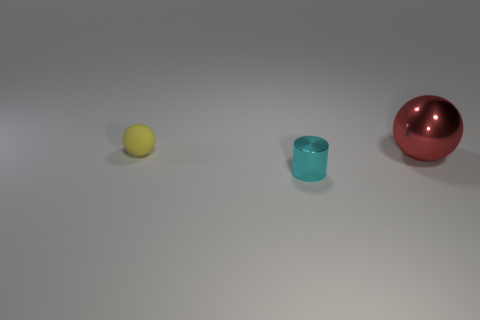Are there any other things that are made of the same material as the yellow sphere?
Provide a succinct answer. No. Is there anything else that is the same size as the red metallic object?
Give a very brief answer. No. There is a cyan object that is the same material as the big sphere; what is its shape?
Offer a very short reply. Cylinder. There is a sphere that is on the right side of the small object that is in front of the tiny yellow sphere; how big is it?
Offer a very short reply. Large. How many tiny things are either gray metal cylinders or metallic objects?
Give a very brief answer. 1. How many other things are the same color as the small ball?
Offer a very short reply. 0. Does the ball that is in front of the small yellow rubber thing have the same size as the ball left of the large red shiny thing?
Offer a very short reply. No. Are the tiny yellow sphere and the large sphere behind the tiny cyan metal object made of the same material?
Offer a very short reply. No. Is the number of cyan cylinders that are in front of the shiny cylinder greater than the number of large red objects that are in front of the large ball?
Provide a short and direct response. No. What is the color of the sphere in front of the tiny thing behind the small shiny cylinder?
Your answer should be very brief. Red. 